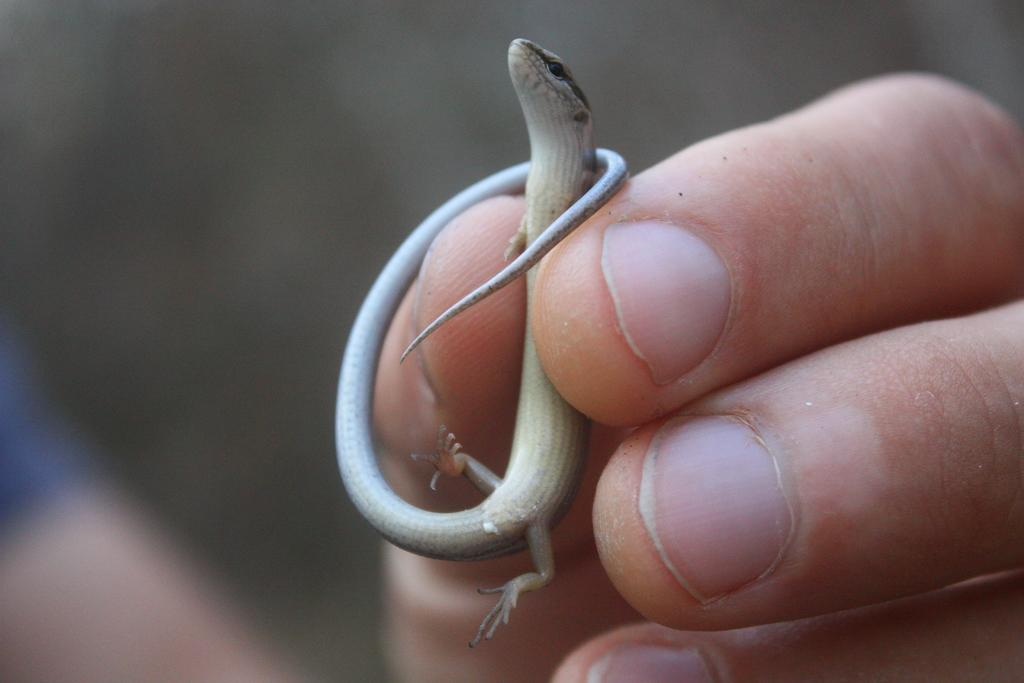What part of a person can be seen in the image? There is a person's hand in the image. What is the person holding in the image? The person is holding a lizard. What type of credit does the person have in the image? There is no mention of credit in the image; it only shows a person's hand holding a lizard. 